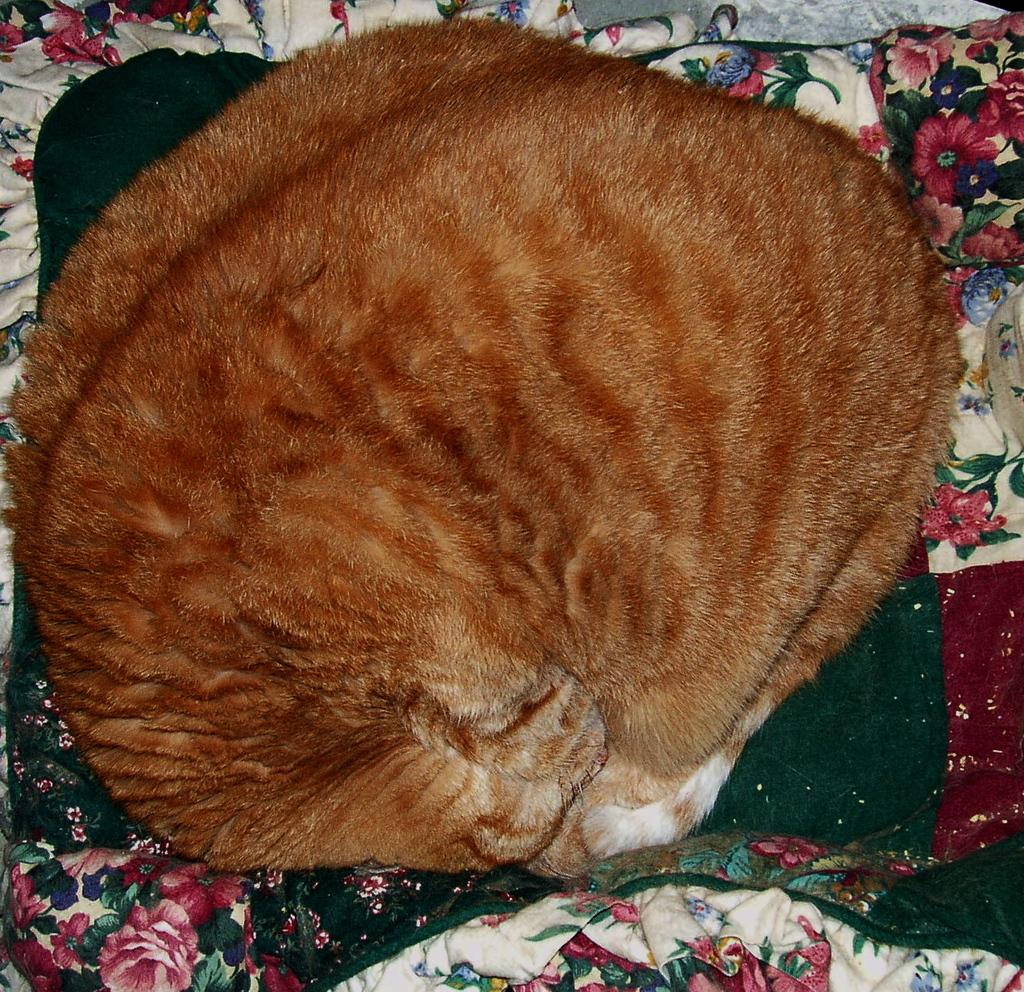What animal can be seen in the picture? There is a cat in the picture. What is the cat doing in the picture? The cat is rolling and sleeping on the bed. What is covering the bed? There is a bed sheet on the bed. What design can be seen on the bed sheet? The bed sheet has designs of flowers on it. What type of jewel can be seen on the cat's collar in the image? There is no jewel or collar visible on the cat in the image. What color is the chalk used to draw the flower designs on the bed sheet? There is no chalk or drawing involved in the image; the bed sheet has printed designs of flowers. 